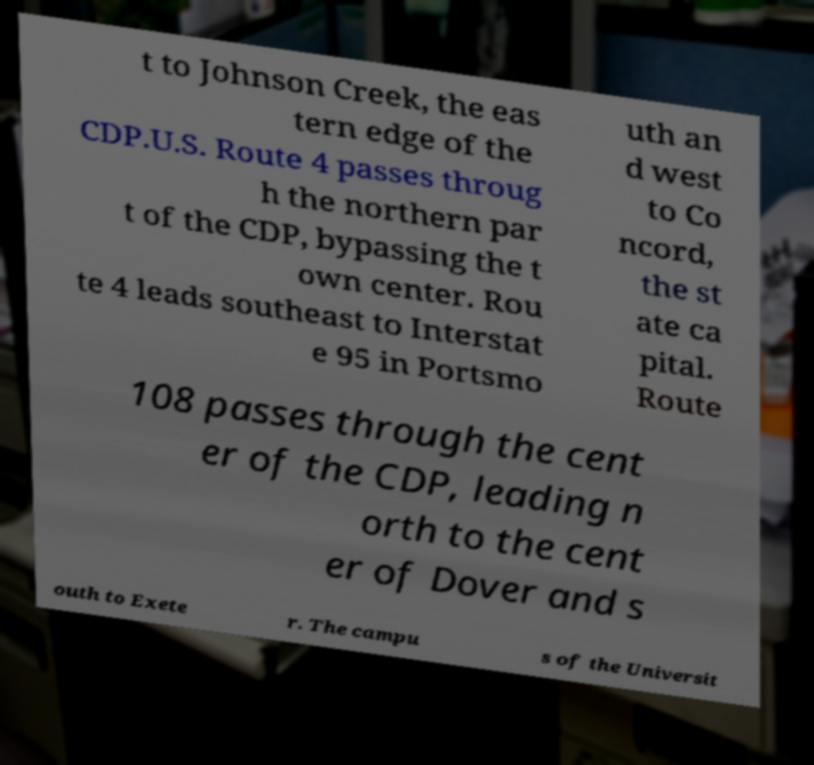Could you assist in decoding the text presented in this image and type it out clearly? t to Johnson Creek, the eas tern edge of the CDP.U.S. Route 4 passes throug h the northern par t of the CDP, bypassing the t own center. Rou te 4 leads southeast to Interstat e 95 in Portsmo uth an d west to Co ncord, the st ate ca pital. Route 108 passes through the cent er of the CDP, leading n orth to the cent er of Dover and s outh to Exete r. The campu s of the Universit 